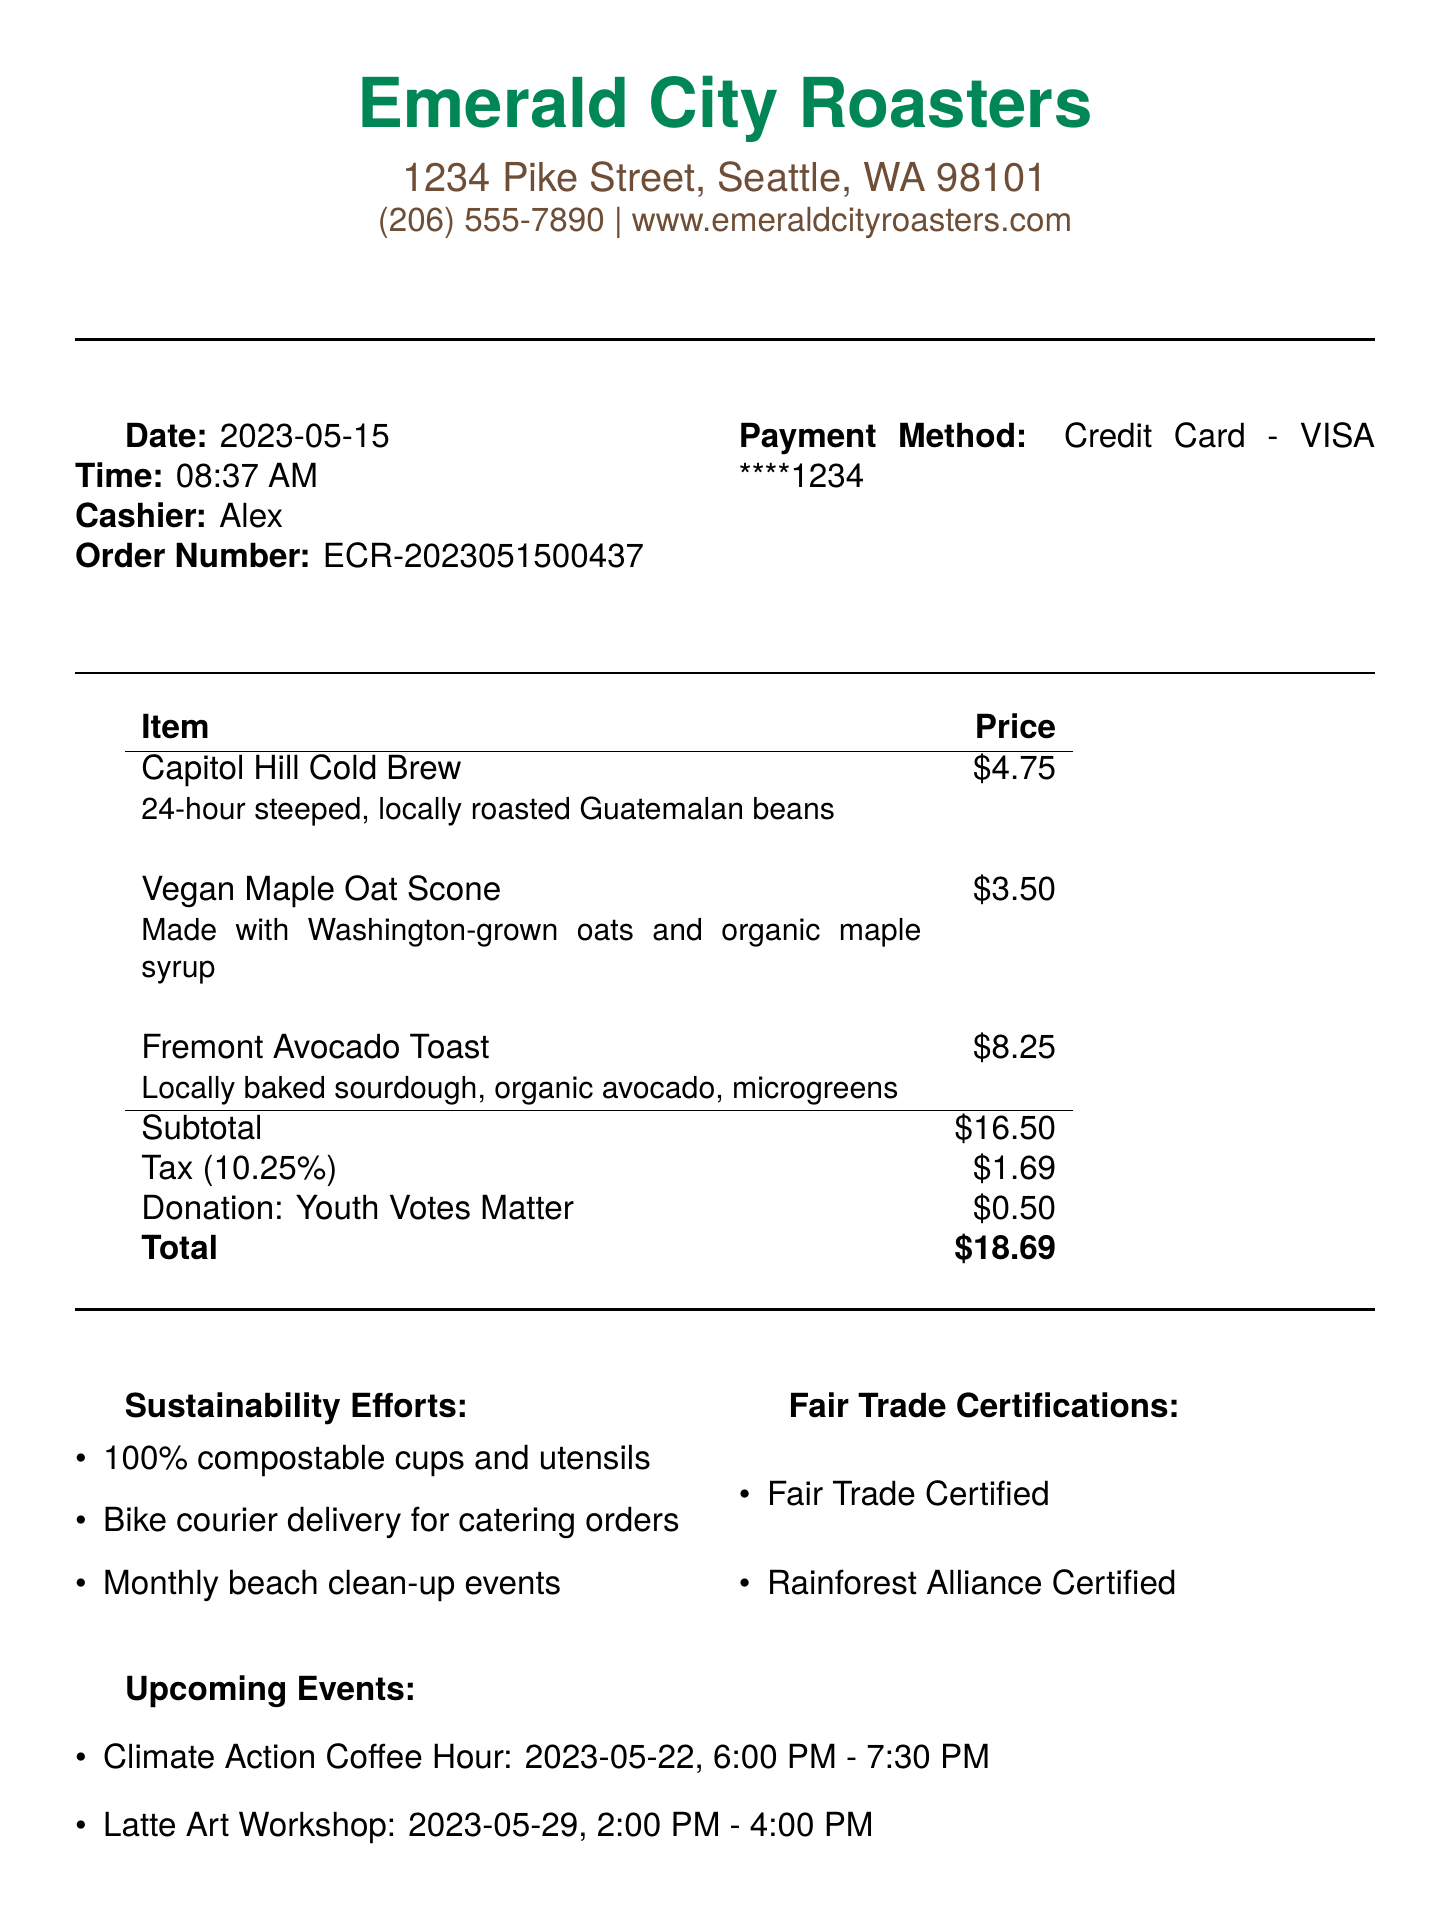What is the shop name? The shop name is presented at the top of the document.
Answer: Emerald City Roasters What is the total amount spent? The total amount is highlighted at the bottom of the itemized receipt.
Answer: $18.69 Who was the cashier? The name of the cashier is mentioned in the document details.
Answer: Alex What date was the order made? The order date is specified in the document.
Answer: 2023-05-15 What is the donation amount? The donation amount is clearly listed in the summary of the receipt.
Answer: $0.50 What type of items were ordered? The items ordered are listed with their descriptions.
Answer: Beverages and baked goods Which sustainability effort mentions delivery? The sustainability efforts section includes various initiatives; one specifically mentions delivery.
Answer: Bike courier delivery for catering orders What is the next loyalty reward threshold? The loyalty program section states the requirement for the next reward.
Answer: 250 What event is happening on May 22, 2023? Upcoming events are listed with their dates and titles.
Answer: Climate Action Coffee Hour 